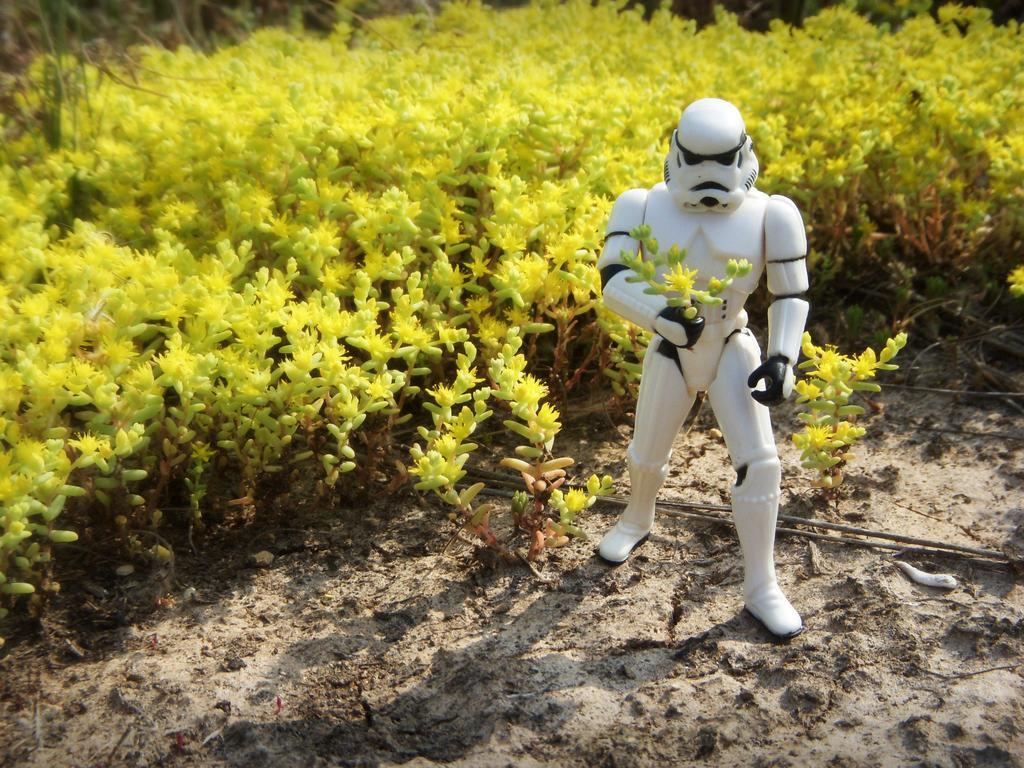How would you summarize this image in a sentence or two? In this image I can see a toy which is white color. background I can see plants in green color. 